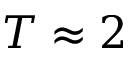<formula> <loc_0><loc_0><loc_500><loc_500>T \approx 2</formula> 